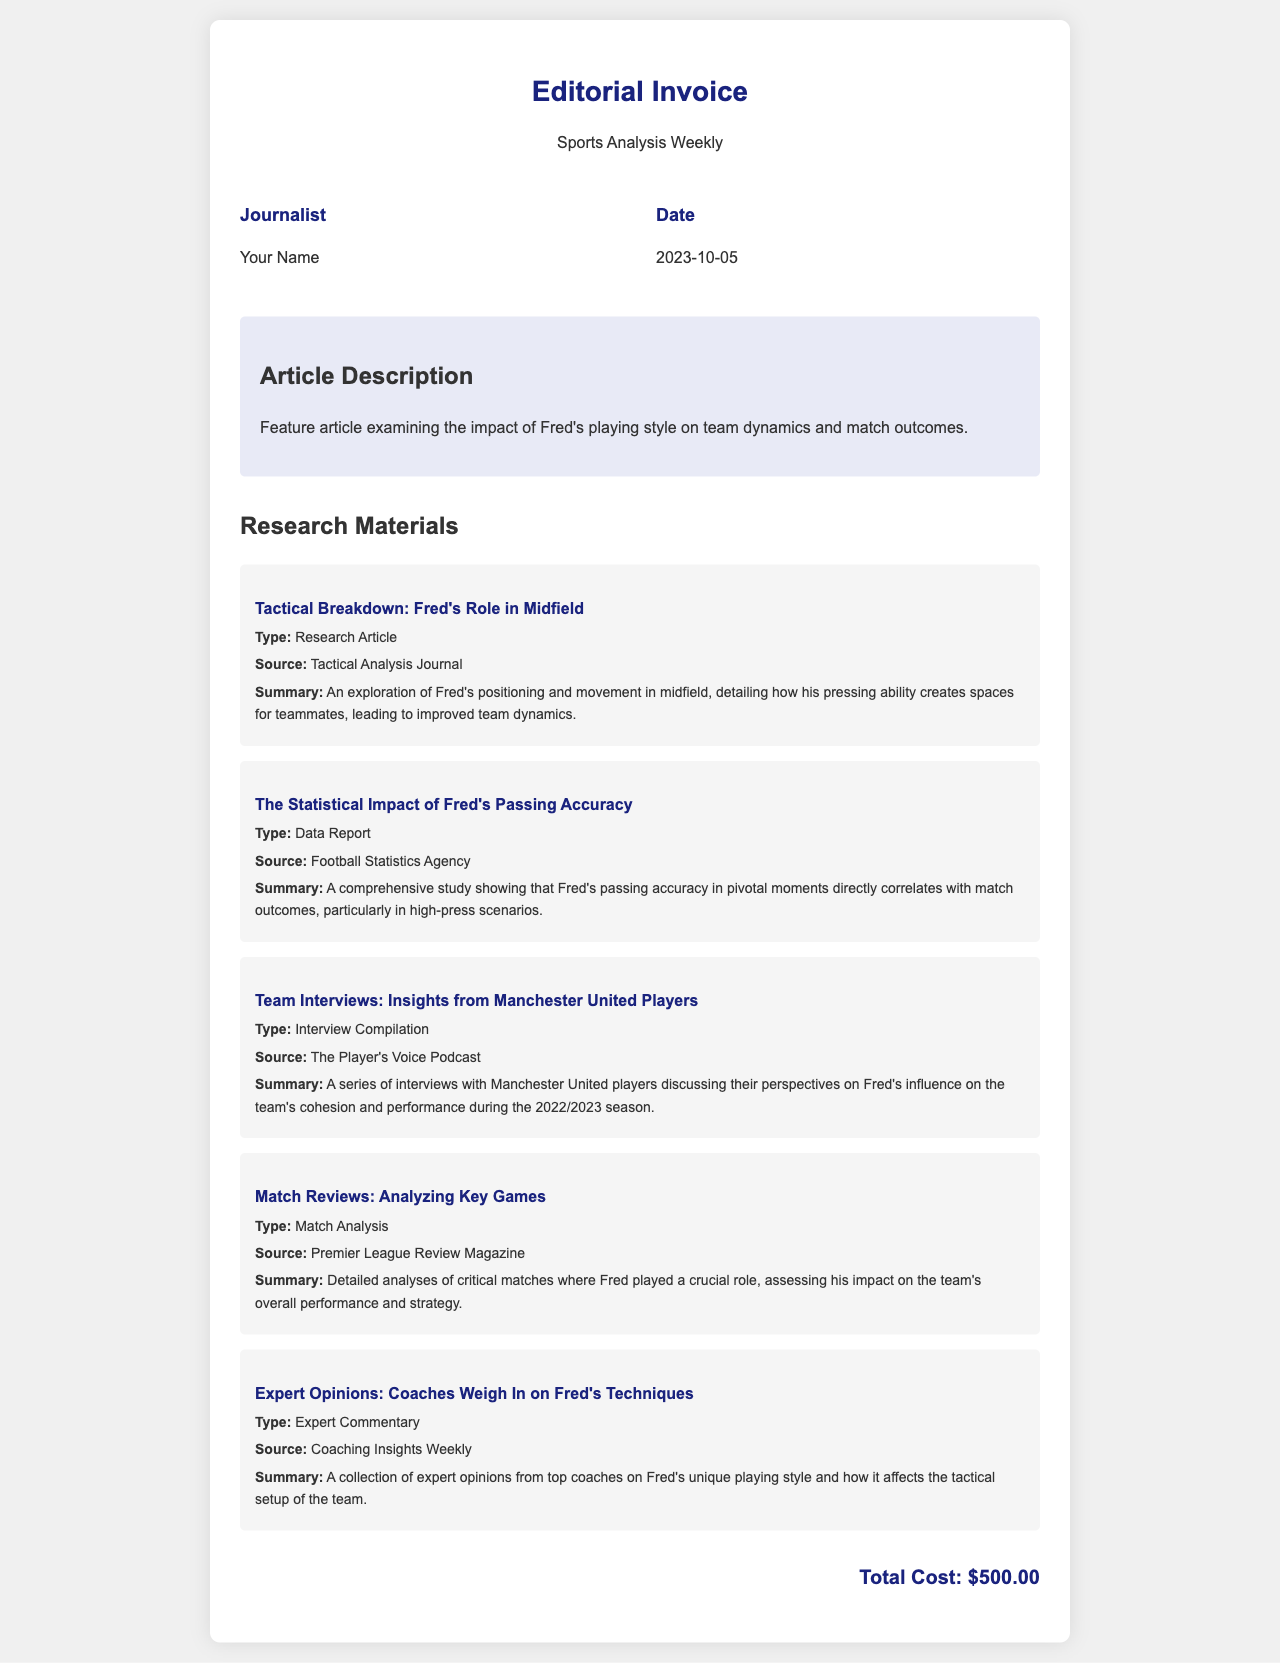what is the total cost? The total cost is specified at the bottom of the document which states the total amount due for the editorial work.
Answer: $500.00 what is the date of the invoice? The date is listed next to the 'Date' heading in the document, indicating when the invoice was generated.
Answer: 2023-10-05 who is the journalist mentioned in the invoice? The journalist's name is located in the 'Journalist' section of the invoice information.
Answer: Your Name what is the title of the feature article? The title is given in the 'Article Description' section, summarizing the core topic of the article being billed.
Answer: Feature article examining the impact of Fred's playing style on team dynamics and match outcomes how many research materials are listed? The number of materials can be counted in the 'Research Materials' section of the document where each material item is described.
Answer: 5 which publication features the tactical breakdown of Fred's role in midfield? The specific publication is listed as the source in the corresponding material item for the tactical breakdown.
Answer: Tactical Analysis Journal what is the type of the research material that discusses passing accuracy? The type is specified in the detailed description of the respective research material in the invoice.
Answer: Data Report which podcast includes interviews about Fred's influence? The specific podcast is cited in the source section of the interview material item.
Answer: The Player's Voice Podcast what color is the header text? The header text color is mentioned in the style of the document, which reflects the design choices made.
Answer: #1a237e 